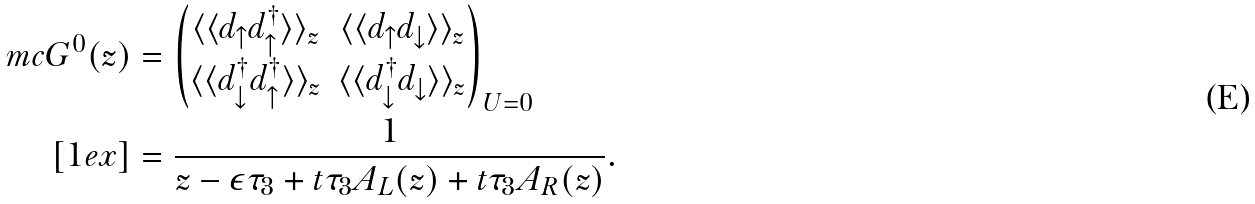Convert formula to latex. <formula><loc_0><loc_0><loc_500><loc_500>\ m c G ^ { 0 } ( z ) & = \begin{pmatrix} \langle \langle d _ { \uparrow } d _ { \uparrow } ^ { \dagger } \rangle \rangle _ { z } & \langle \langle d _ { \uparrow } d _ { \downarrow } \rangle \rangle _ { z } \\ \langle \langle d _ { \downarrow } ^ { \dagger } d _ { \uparrow } ^ { \dagger } \rangle \rangle _ { z } & \langle \langle d _ { \downarrow } ^ { \dagger } d _ { \downarrow } \rangle \rangle _ { z } \end{pmatrix} _ { U = 0 } \\ [ 1 e x ] & = \frac { 1 } { z - \epsilon \tau _ { 3 } + t \tau _ { 3 } A _ { L } ( z ) + t \tau _ { 3 } A _ { R } ( z ) } .</formula> 